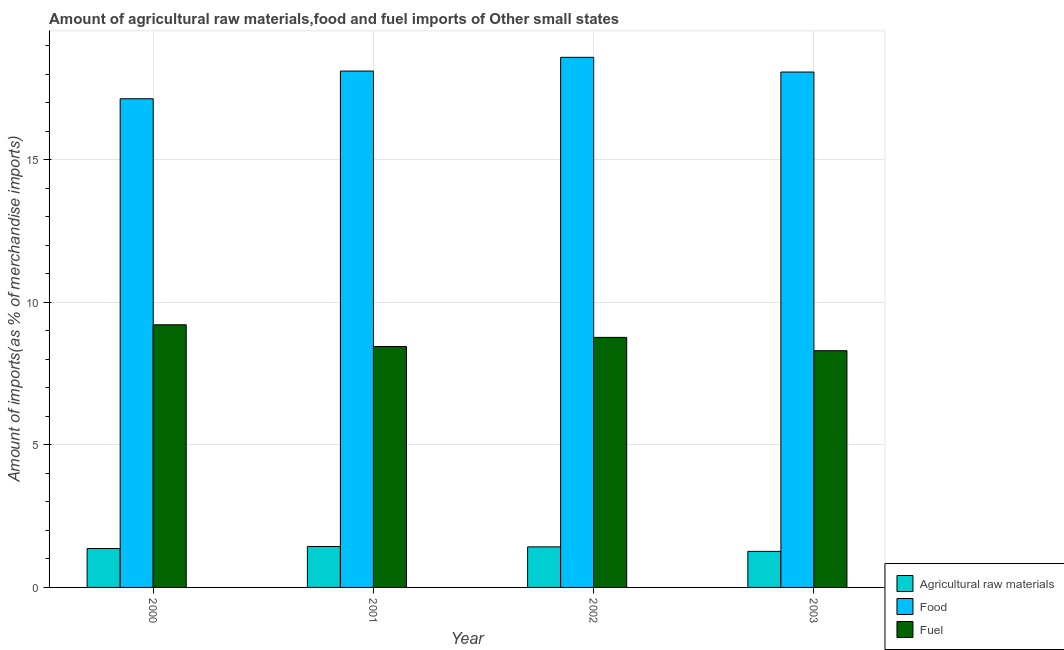How many different coloured bars are there?
Offer a terse response. 3. How many groups of bars are there?
Ensure brevity in your answer.  4. Are the number of bars per tick equal to the number of legend labels?
Offer a very short reply. Yes. How many bars are there on the 1st tick from the left?
Offer a very short reply. 3. What is the label of the 2nd group of bars from the left?
Keep it short and to the point. 2001. What is the percentage of food imports in 2002?
Offer a very short reply. 18.6. Across all years, what is the maximum percentage of fuel imports?
Make the answer very short. 9.21. Across all years, what is the minimum percentage of raw materials imports?
Make the answer very short. 1.27. In which year was the percentage of raw materials imports maximum?
Offer a very short reply. 2001. In which year was the percentage of fuel imports minimum?
Offer a terse response. 2003. What is the total percentage of raw materials imports in the graph?
Provide a short and direct response. 5.49. What is the difference between the percentage of food imports in 2001 and that in 2002?
Provide a succinct answer. -0.48. What is the difference between the percentage of fuel imports in 2003 and the percentage of raw materials imports in 2001?
Make the answer very short. -0.15. What is the average percentage of food imports per year?
Provide a succinct answer. 17.98. In how many years, is the percentage of raw materials imports greater than 18 %?
Provide a short and direct response. 0. What is the ratio of the percentage of fuel imports in 2001 to that in 2002?
Give a very brief answer. 0.96. Is the percentage of fuel imports in 2000 less than that in 2002?
Ensure brevity in your answer.  No. What is the difference between the highest and the second highest percentage of food imports?
Your response must be concise. 0.48. What is the difference between the highest and the lowest percentage of fuel imports?
Ensure brevity in your answer.  0.91. In how many years, is the percentage of fuel imports greater than the average percentage of fuel imports taken over all years?
Ensure brevity in your answer.  2. Is the sum of the percentage of fuel imports in 2000 and 2001 greater than the maximum percentage of food imports across all years?
Offer a terse response. Yes. What does the 3rd bar from the left in 2002 represents?
Provide a succinct answer. Fuel. What does the 2nd bar from the right in 2003 represents?
Keep it short and to the point. Food. How many bars are there?
Your answer should be compact. 12. How many years are there in the graph?
Your response must be concise. 4. What is the difference between two consecutive major ticks on the Y-axis?
Your answer should be very brief. 5. Does the graph contain grids?
Give a very brief answer. Yes. How are the legend labels stacked?
Offer a terse response. Vertical. What is the title of the graph?
Make the answer very short. Amount of agricultural raw materials,food and fuel imports of Other small states. What is the label or title of the X-axis?
Your answer should be compact. Year. What is the label or title of the Y-axis?
Your response must be concise. Amount of imports(as % of merchandise imports). What is the Amount of imports(as % of merchandise imports) in Agricultural raw materials in 2000?
Keep it short and to the point. 1.36. What is the Amount of imports(as % of merchandise imports) in Food in 2000?
Your answer should be very brief. 17.14. What is the Amount of imports(as % of merchandise imports) of Fuel in 2000?
Offer a very short reply. 9.21. What is the Amount of imports(as % of merchandise imports) in Agricultural raw materials in 2001?
Your answer should be very brief. 1.44. What is the Amount of imports(as % of merchandise imports) in Food in 2001?
Give a very brief answer. 18.12. What is the Amount of imports(as % of merchandise imports) in Fuel in 2001?
Offer a terse response. 8.45. What is the Amount of imports(as % of merchandise imports) of Agricultural raw materials in 2002?
Offer a very short reply. 1.42. What is the Amount of imports(as % of merchandise imports) in Food in 2002?
Your answer should be compact. 18.6. What is the Amount of imports(as % of merchandise imports) in Fuel in 2002?
Provide a succinct answer. 8.77. What is the Amount of imports(as % of merchandise imports) of Agricultural raw materials in 2003?
Ensure brevity in your answer.  1.27. What is the Amount of imports(as % of merchandise imports) in Food in 2003?
Your answer should be very brief. 18.08. What is the Amount of imports(as % of merchandise imports) of Fuel in 2003?
Offer a very short reply. 8.31. Across all years, what is the maximum Amount of imports(as % of merchandise imports) in Agricultural raw materials?
Make the answer very short. 1.44. Across all years, what is the maximum Amount of imports(as % of merchandise imports) of Food?
Provide a short and direct response. 18.6. Across all years, what is the maximum Amount of imports(as % of merchandise imports) in Fuel?
Your answer should be compact. 9.21. Across all years, what is the minimum Amount of imports(as % of merchandise imports) in Agricultural raw materials?
Your response must be concise. 1.27. Across all years, what is the minimum Amount of imports(as % of merchandise imports) of Food?
Provide a succinct answer. 17.14. Across all years, what is the minimum Amount of imports(as % of merchandise imports) of Fuel?
Your answer should be compact. 8.31. What is the total Amount of imports(as % of merchandise imports) in Agricultural raw materials in the graph?
Provide a short and direct response. 5.49. What is the total Amount of imports(as % of merchandise imports) of Food in the graph?
Give a very brief answer. 71.94. What is the total Amount of imports(as % of merchandise imports) of Fuel in the graph?
Offer a very short reply. 34.74. What is the difference between the Amount of imports(as % of merchandise imports) of Agricultural raw materials in 2000 and that in 2001?
Offer a terse response. -0.07. What is the difference between the Amount of imports(as % of merchandise imports) in Food in 2000 and that in 2001?
Keep it short and to the point. -0.97. What is the difference between the Amount of imports(as % of merchandise imports) of Fuel in 2000 and that in 2001?
Your response must be concise. 0.76. What is the difference between the Amount of imports(as % of merchandise imports) in Agricultural raw materials in 2000 and that in 2002?
Provide a succinct answer. -0.06. What is the difference between the Amount of imports(as % of merchandise imports) of Food in 2000 and that in 2002?
Offer a very short reply. -1.45. What is the difference between the Amount of imports(as % of merchandise imports) in Fuel in 2000 and that in 2002?
Your answer should be compact. 0.44. What is the difference between the Amount of imports(as % of merchandise imports) in Agricultural raw materials in 2000 and that in 2003?
Make the answer very short. 0.1. What is the difference between the Amount of imports(as % of merchandise imports) in Food in 2000 and that in 2003?
Provide a succinct answer. -0.94. What is the difference between the Amount of imports(as % of merchandise imports) in Fuel in 2000 and that in 2003?
Your answer should be compact. 0.91. What is the difference between the Amount of imports(as % of merchandise imports) of Agricultural raw materials in 2001 and that in 2002?
Your response must be concise. 0.01. What is the difference between the Amount of imports(as % of merchandise imports) in Food in 2001 and that in 2002?
Keep it short and to the point. -0.48. What is the difference between the Amount of imports(as % of merchandise imports) in Fuel in 2001 and that in 2002?
Keep it short and to the point. -0.32. What is the difference between the Amount of imports(as % of merchandise imports) in Agricultural raw materials in 2001 and that in 2003?
Make the answer very short. 0.17. What is the difference between the Amount of imports(as % of merchandise imports) of Food in 2001 and that in 2003?
Offer a terse response. 0.03. What is the difference between the Amount of imports(as % of merchandise imports) of Fuel in 2001 and that in 2003?
Offer a very short reply. 0.15. What is the difference between the Amount of imports(as % of merchandise imports) in Agricultural raw materials in 2002 and that in 2003?
Your answer should be compact. 0.16. What is the difference between the Amount of imports(as % of merchandise imports) of Food in 2002 and that in 2003?
Offer a terse response. 0.52. What is the difference between the Amount of imports(as % of merchandise imports) in Fuel in 2002 and that in 2003?
Offer a very short reply. 0.47. What is the difference between the Amount of imports(as % of merchandise imports) of Agricultural raw materials in 2000 and the Amount of imports(as % of merchandise imports) of Food in 2001?
Your answer should be compact. -16.75. What is the difference between the Amount of imports(as % of merchandise imports) of Agricultural raw materials in 2000 and the Amount of imports(as % of merchandise imports) of Fuel in 2001?
Provide a short and direct response. -7.09. What is the difference between the Amount of imports(as % of merchandise imports) of Food in 2000 and the Amount of imports(as % of merchandise imports) of Fuel in 2001?
Give a very brief answer. 8.69. What is the difference between the Amount of imports(as % of merchandise imports) in Agricultural raw materials in 2000 and the Amount of imports(as % of merchandise imports) in Food in 2002?
Provide a short and direct response. -17.23. What is the difference between the Amount of imports(as % of merchandise imports) of Agricultural raw materials in 2000 and the Amount of imports(as % of merchandise imports) of Fuel in 2002?
Offer a very short reply. -7.41. What is the difference between the Amount of imports(as % of merchandise imports) in Food in 2000 and the Amount of imports(as % of merchandise imports) in Fuel in 2002?
Your answer should be compact. 8.37. What is the difference between the Amount of imports(as % of merchandise imports) of Agricultural raw materials in 2000 and the Amount of imports(as % of merchandise imports) of Food in 2003?
Provide a succinct answer. -16.72. What is the difference between the Amount of imports(as % of merchandise imports) of Agricultural raw materials in 2000 and the Amount of imports(as % of merchandise imports) of Fuel in 2003?
Provide a succinct answer. -6.94. What is the difference between the Amount of imports(as % of merchandise imports) of Food in 2000 and the Amount of imports(as % of merchandise imports) of Fuel in 2003?
Give a very brief answer. 8.84. What is the difference between the Amount of imports(as % of merchandise imports) of Agricultural raw materials in 2001 and the Amount of imports(as % of merchandise imports) of Food in 2002?
Give a very brief answer. -17.16. What is the difference between the Amount of imports(as % of merchandise imports) in Agricultural raw materials in 2001 and the Amount of imports(as % of merchandise imports) in Fuel in 2002?
Make the answer very short. -7.34. What is the difference between the Amount of imports(as % of merchandise imports) in Food in 2001 and the Amount of imports(as % of merchandise imports) in Fuel in 2002?
Offer a terse response. 9.34. What is the difference between the Amount of imports(as % of merchandise imports) in Agricultural raw materials in 2001 and the Amount of imports(as % of merchandise imports) in Food in 2003?
Make the answer very short. -16.64. What is the difference between the Amount of imports(as % of merchandise imports) in Agricultural raw materials in 2001 and the Amount of imports(as % of merchandise imports) in Fuel in 2003?
Provide a short and direct response. -6.87. What is the difference between the Amount of imports(as % of merchandise imports) in Food in 2001 and the Amount of imports(as % of merchandise imports) in Fuel in 2003?
Provide a succinct answer. 9.81. What is the difference between the Amount of imports(as % of merchandise imports) in Agricultural raw materials in 2002 and the Amount of imports(as % of merchandise imports) in Food in 2003?
Offer a terse response. -16.66. What is the difference between the Amount of imports(as % of merchandise imports) of Agricultural raw materials in 2002 and the Amount of imports(as % of merchandise imports) of Fuel in 2003?
Offer a terse response. -6.88. What is the difference between the Amount of imports(as % of merchandise imports) in Food in 2002 and the Amount of imports(as % of merchandise imports) in Fuel in 2003?
Provide a short and direct response. 10.29. What is the average Amount of imports(as % of merchandise imports) in Agricultural raw materials per year?
Provide a succinct answer. 1.37. What is the average Amount of imports(as % of merchandise imports) in Food per year?
Provide a succinct answer. 17.98. What is the average Amount of imports(as % of merchandise imports) of Fuel per year?
Ensure brevity in your answer.  8.69. In the year 2000, what is the difference between the Amount of imports(as % of merchandise imports) of Agricultural raw materials and Amount of imports(as % of merchandise imports) of Food?
Offer a terse response. -15.78. In the year 2000, what is the difference between the Amount of imports(as % of merchandise imports) of Agricultural raw materials and Amount of imports(as % of merchandise imports) of Fuel?
Make the answer very short. -7.85. In the year 2000, what is the difference between the Amount of imports(as % of merchandise imports) of Food and Amount of imports(as % of merchandise imports) of Fuel?
Your answer should be compact. 7.93. In the year 2001, what is the difference between the Amount of imports(as % of merchandise imports) of Agricultural raw materials and Amount of imports(as % of merchandise imports) of Food?
Ensure brevity in your answer.  -16.68. In the year 2001, what is the difference between the Amount of imports(as % of merchandise imports) of Agricultural raw materials and Amount of imports(as % of merchandise imports) of Fuel?
Make the answer very short. -7.02. In the year 2001, what is the difference between the Amount of imports(as % of merchandise imports) of Food and Amount of imports(as % of merchandise imports) of Fuel?
Your response must be concise. 9.66. In the year 2002, what is the difference between the Amount of imports(as % of merchandise imports) of Agricultural raw materials and Amount of imports(as % of merchandise imports) of Food?
Your response must be concise. -17.17. In the year 2002, what is the difference between the Amount of imports(as % of merchandise imports) in Agricultural raw materials and Amount of imports(as % of merchandise imports) in Fuel?
Provide a short and direct response. -7.35. In the year 2002, what is the difference between the Amount of imports(as % of merchandise imports) of Food and Amount of imports(as % of merchandise imports) of Fuel?
Your response must be concise. 9.82. In the year 2003, what is the difference between the Amount of imports(as % of merchandise imports) of Agricultural raw materials and Amount of imports(as % of merchandise imports) of Food?
Offer a terse response. -16.82. In the year 2003, what is the difference between the Amount of imports(as % of merchandise imports) in Agricultural raw materials and Amount of imports(as % of merchandise imports) in Fuel?
Provide a succinct answer. -7.04. In the year 2003, what is the difference between the Amount of imports(as % of merchandise imports) in Food and Amount of imports(as % of merchandise imports) in Fuel?
Keep it short and to the point. 9.78. What is the ratio of the Amount of imports(as % of merchandise imports) of Agricultural raw materials in 2000 to that in 2001?
Your answer should be compact. 0.95. What is the ratio of the Amount of imports(as % of merchandise imports) of Food in 2000 to that in 2001?
Keep it short and to the point. 0.95. What is the ratio of the Amount of imports(as % of merchandise imports) of Fuel in 2000 to that in 2001?
Offer a very short reply. 1.09. What is the ratio of the Amount of imports(as % of merchandise imports) in Agricultural raw materials in 2000 to that in 2002?
Provide a succinct answer. 0.96. What is the ratio of the Amount of imports(as % of merchandise imports) of Food in 2000 to that in 2002?
Provide a succinct answer. 0.92. What is the ratio of the Amount of imports(as % of merchandise imports) of Fuel in 2000 to that in 2002?
Offer a terse response. 1.05. What is the ratio of the Amount of imports(as % of merchandise imports) of Agricultural raw materials in 2000 to that in 2003?
Offer a terse response. 1.08. What is the ratio of the Amount of imports(as % of merchandise imports) of Food in 2000 to that in 2003?
Offer a very short reply. 0.95. What is the ratio of the Amount of imports(as % of merchandise imports) in Fuel in 2000 to that in 2003?
Your response must be concise. 1.11. What is the ratio of the Amount of imports(as % of merchandise imports) of Agricultural raw materials in 2001 to that in 2002?
Give a very brief answer. 1.01. What is the ratio of the Amount of imports(as % of merchandise imports) of Food in 2001 to that in 2002?
Your answer should be very brief. 0.97. What is the ratio of the Amount of imports(as % of merchandise imports) in Fuel in 2001 to that in 2002?
Give a very brief answer. 0.96. What is the ratio of the Amount of imports(as % of merchandise imports) in Agricultural raw materials in 2001 to that in 2003?
Offer a terse response. 1.14. What is the ratio of the Amount of imports(as % of merchandise imports) of Food in 2001 to that in 2003?
Your answer should be very brief. 1. What is the ratio of the Amount of imports(as % of merchandise imports) of Fuel in 2001 to that in 2003?
Ensure brevity in your answer.  1.02. What is the ratio of the Amount of imports(as % of merchandise imports) of Agricultural raw materials in 2002 to that in 2003?
Keep it short and to the point. 1.12. What is the ratio of the Amount of imports(as % of merchandise imports) of Food in 2002 to that in 2003?
Provide a succinct answer. 1.03. What is the ratio of the Amount of imports(as % of merchandise imports) in Fuel in 2002 to that in 2003?
Make the answer very short. 1.06. What is the difference between the highest and the second highest Amount of imports(as % of merchandise imports) in Agricultural raw materials?
Your answer should be compact. 0.01. What is the difference between the highest and the second highest Amount of imports(as % of merchandise imports) of Food?
Give a very brief answer. 0.48. What is the difference between the highest and the second highest Amount of imports(as % of merchandise imports) in Fuel?
Keep it short and to the point. 0.44. What is the difference between the highest and the lowest Amount of imports(as % of merchandise imports) of Agricultural raw materials?
Make the answer very short. 0.17. What is the difference between the highest and the lowest Amount of imports(as % of merchandise imports) in Food?
Give a very brief answer. 1.45. What is the difference between the highest and the lowest Amount of imports(as % of merchandise imports) of Fuel?
Keep it short and to the point. 0.91. 